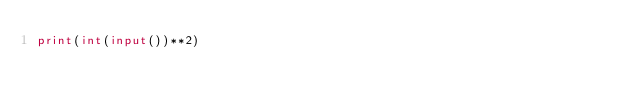<code> <loc_0><loc_0><loc_500><loc_500><_Python_>print(int(input())**2)</code> 